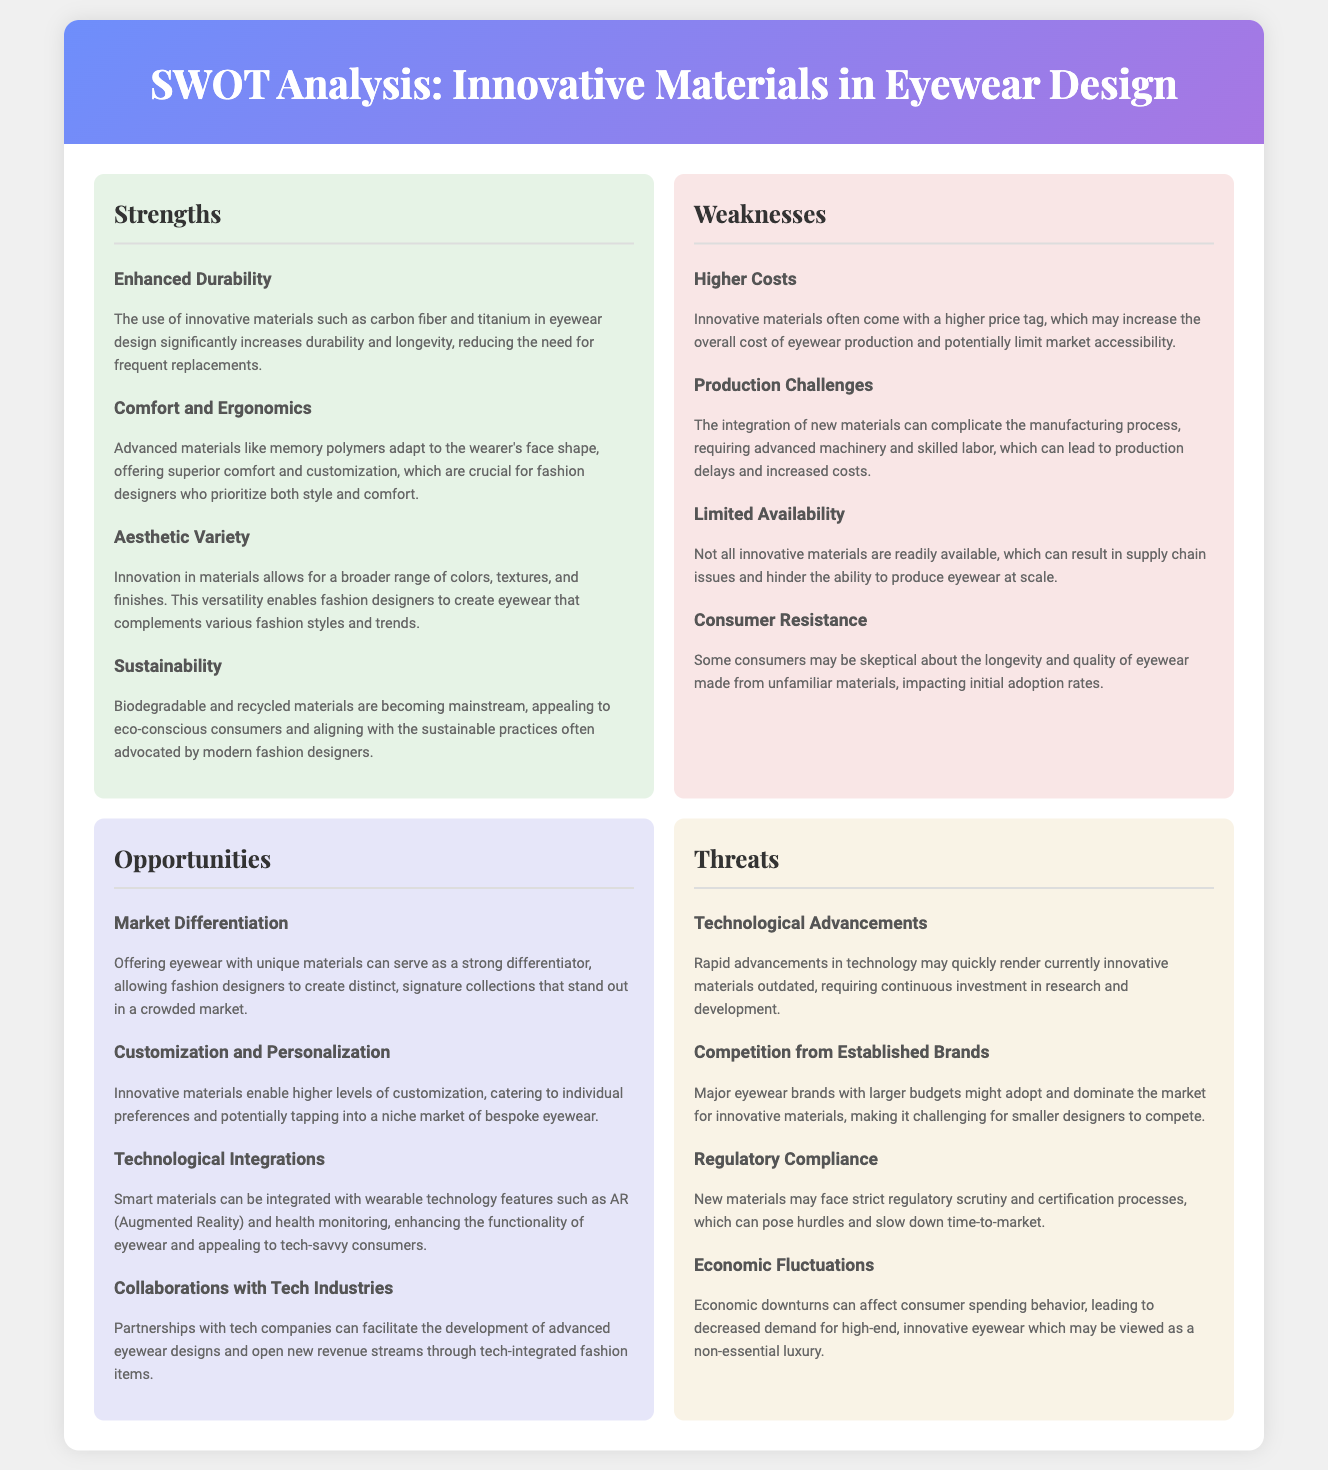What are some innovative materials mentioned for enhancing durability? The strengths section mentions carbon fiber and titanium as innovative materials that increase durability in eyewear design.
Answer: carbon fiber and titanium What is a key consumer concern regarding innovative materials? In the weaknesses section, it specifically states that some consumers may be skeptical about the longevity and quality of eyewear made from unfamiliar materials.
Answer: Consumer Resistance What opportunity involves creating unique eyewear collections? The opportunities section discusses market differentiation, which allows for creating distinct eyewear collections using innovative materials.
Answer: Market Differentiation What is a technological integration mentioned for innovative eyewear? The opportunities section mentions the integration of smart materials with wearable technology features such as Augmented Reality.
Answer: Augmented Reality Which material type is highlighted for sustainability? The strengths section emphasizes biodegradable and recycled materials as a sustainable practice in eyewear design.
Answer: biodegradable and recycled materials What is a threat from established brands? The threats section notes that major eyewear brands with larger budgets might adopt and dominate the market for innovative materials.
Answer: Competition from Established Brands What can complicate the manufacturing process of eyewear? Under weaknesses, the document states that the integration of new materials can complicate the manufacturing process, requiring advanced machinery.
Answer: Production Challenges What does customization in innovative materials cater to? The opportunities section explains that innovative materials enable higher levels of customization, catering to individual preferences.
Answer: individual preferences 